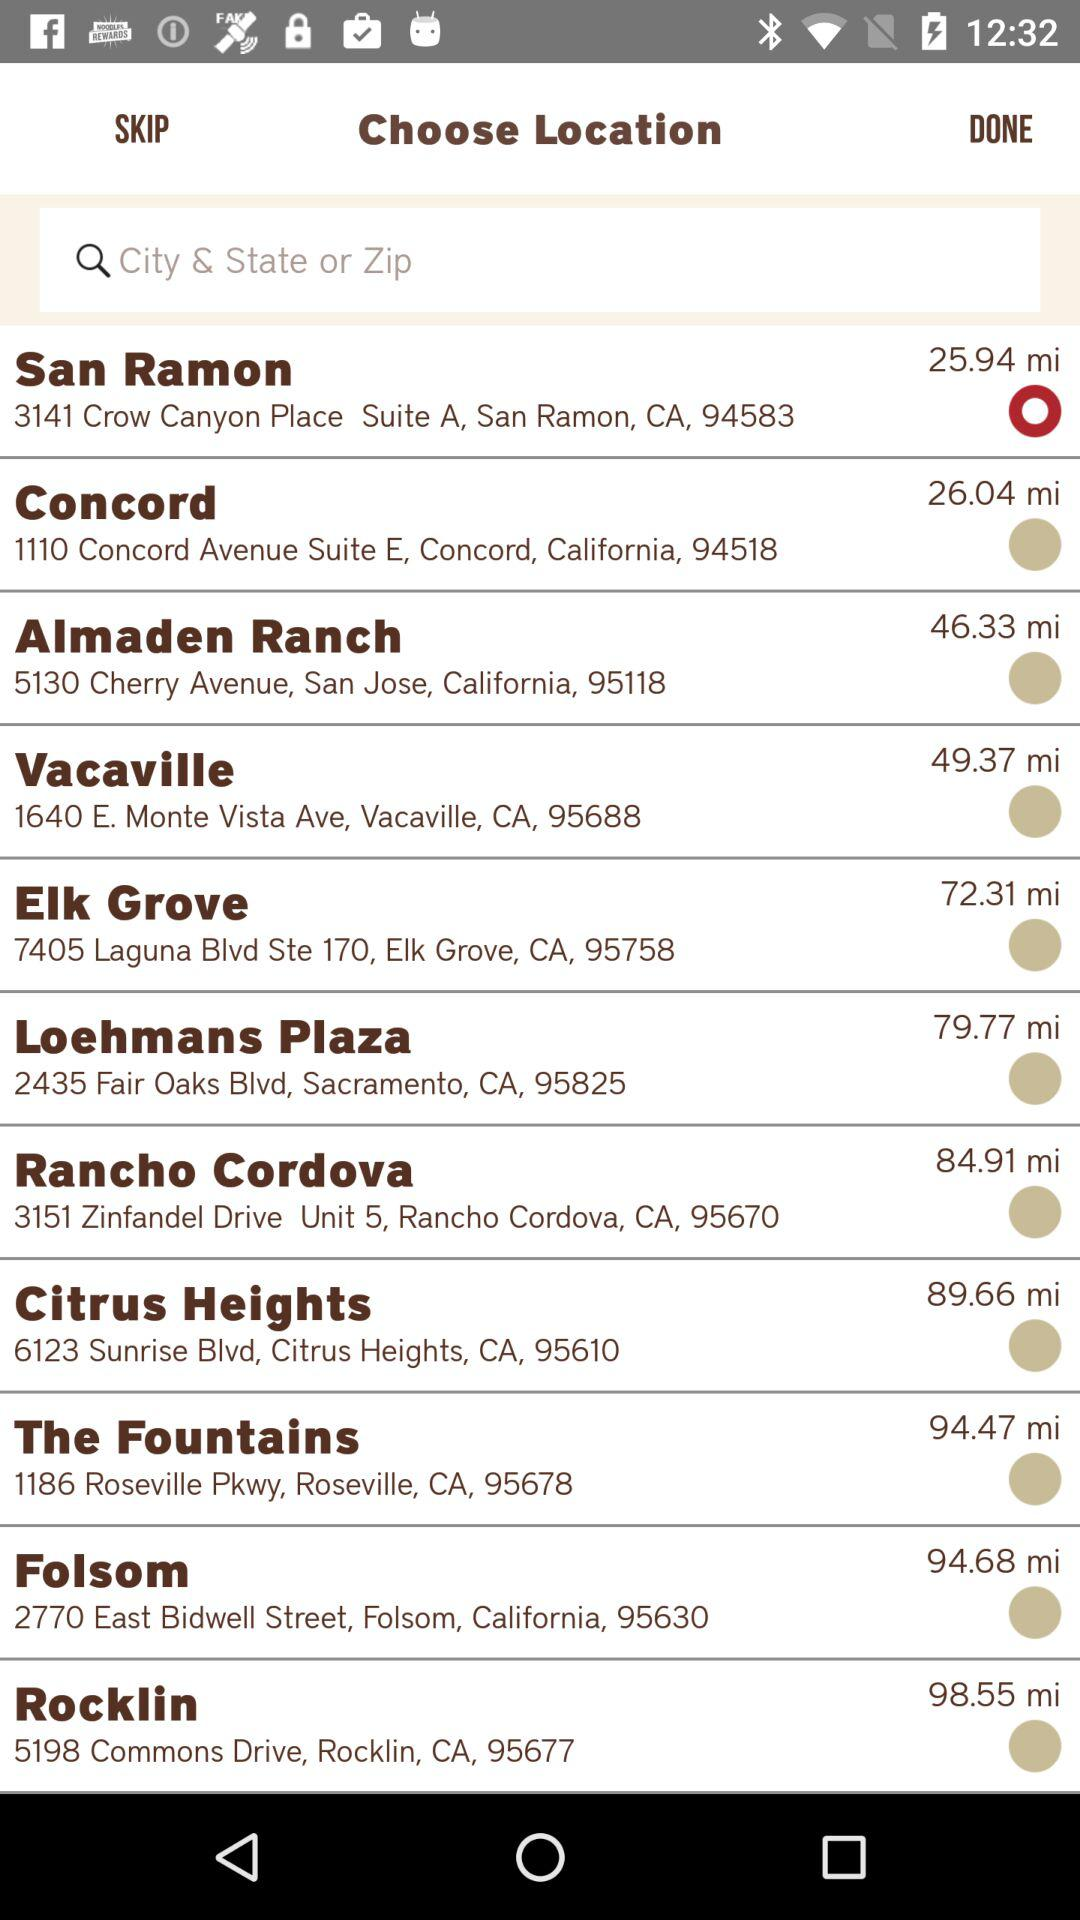Which city has the Zip code 95677? The city is Rocklin. 